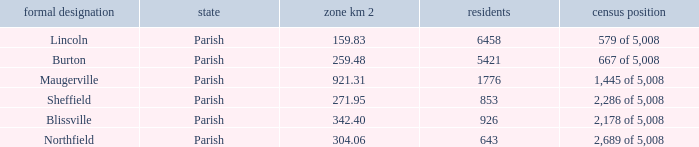What are the official name(s) of places with an area of 304.06 km2? Northfield. 